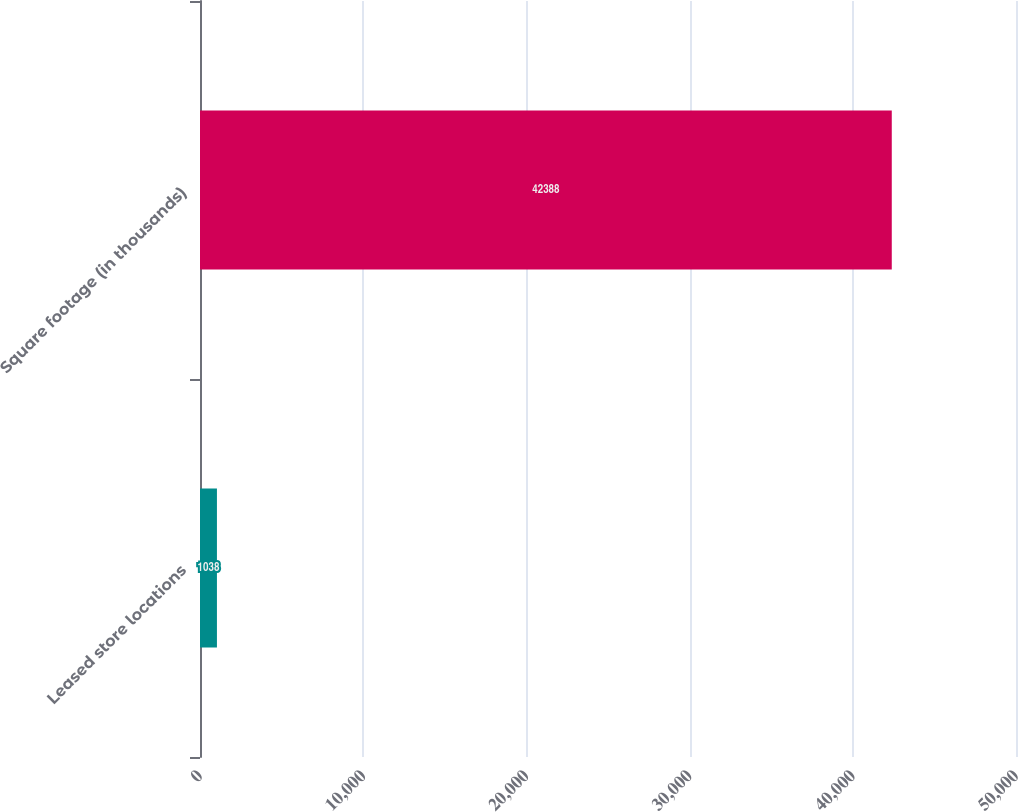<chart> <loc_0><loc_0><loc_500><loc_500><bar_chart><fcel>Leased store locations<fcel>Square footage (in thousands)<nl><fcel>1038<fcel>42388<nl></chart> 